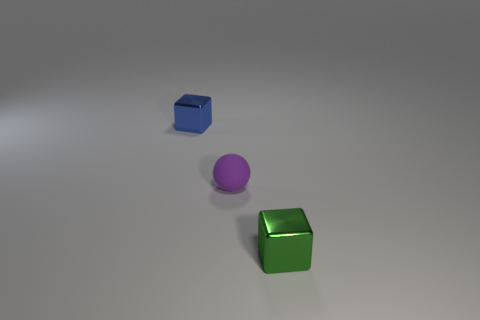What could be the purpose of arranging these objects like this? The arrangement could serve various purposes such as an artistic display, a part of a color study, or a setup for a physics demonstration about shapes and light reflection. Do the objects have any visible signs of wear or are they new? The objects appear to be in pristine condition with no visible signs of wear, suggesting that they are either new or have been well-maintained. 